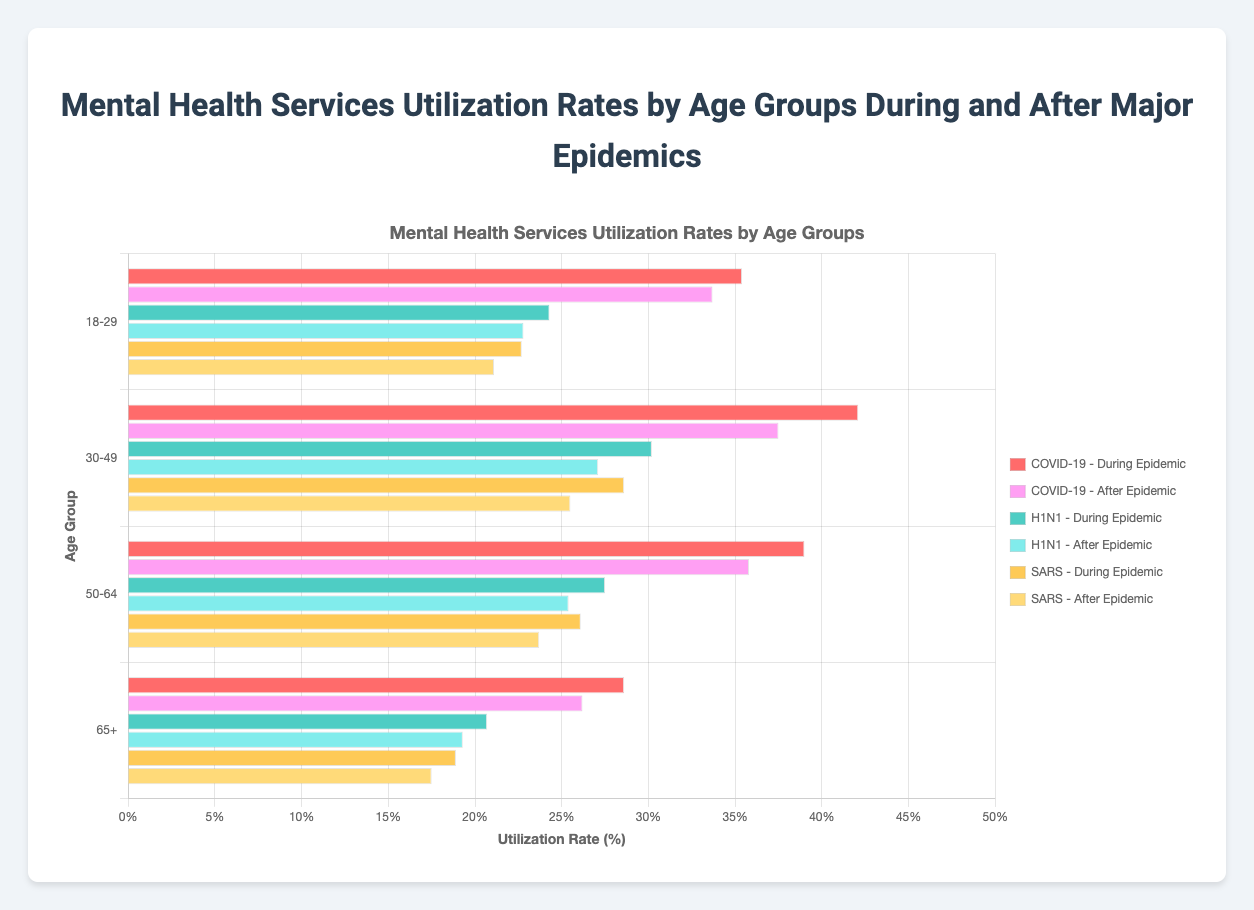Which age group had the highest utilization rate during the COVID-19 epidemic? To find the age group with the highest utilization rate during the COVID-19 epidemic, look for the highest bar that corresponds to the "During Epidemic" period for "COVID-19". The age group 30-49 has the highest utilization rate at 42.1%.
Answer: 30-49 What is the difference in utilization rates of mental health services between the 18-29 age group and the 65+ age group after the H1N1 epidemic? Find the utilization rates for both age groups after the H1N1 epidemic. For the 18-29 age group, the rate is 22.8%, and for the 65+ age group, it is 19.3%. The difference is 22.8% - 19.3% = 3.5%.
Answer: 3.5% During the SARS epidemic, which age group had the lowest utilization rate? Look for the lowest bar corresponding to the "During Epidemic" period for "SARS". The lowest utilization rate during the SARS epidemic is for the 65+ age group, which is 18.9%.
Answer: 65+ On average, how did the utilization rates for mental health services change for the age group 50-64 from during to after the COVID-19 epidemic? Find the utilization rates for the 50-64 age group during and after the COVID-19 epidemic. During the COVID-19 epidemic, the rate is 39.0%, and after the epidemic, it is 35.8%. The average change is calculated as (39.0% - 35.8%) / 2 = 1.6%.
Answer: 1.6% During the H1N1 epidemic, which age group had a higher utilization rate: 18-29 or 30-49? Compare the utilization rates during the H1N1 epidemic for the age groups 18-29 and 30-49. The 18-29 age group had a rate of 24.3% while the 30-49 age group had a rate of 30.2%. The 30-49 age group had a higher utilization rate.
Answer: 30-49 What is the total utilization rate for mental health services for the 30-49 age group during all three epidemics? Find the utilization rates for the 30-49 age group during each epidemic (COVID-19, H1N1, SARS). Add these rates: 42.1% (COVID-19) + 30.2% (H1N1) + 28.6% (SARS) = 100.9%.
Answer: 100.9% What was the average utilization rate for the 65+ age group after all three epidemics? Find the utilization rates for the 65+ age group after each epidemic (COVID-19, H1N1, SARS). Calculate the average: (26.2% + 19.3% + 17.5%) / 3 = 21.0%.
Answer: 21.0% Which age group had the most significant decrease in utilization rates from during to after the SARS epidemic? Look at the utilization rates for each age group during and after the SARS epidemic and calculate the decrease. The decreases are: 18-29: 22.7% to 21.1% (1.6%), 30-49: 28.6% to 25.5% (3.1%), 50-64: 26.1% to 23.7% (2.4%), 65+: 18.9% to 17.5% (1.4%). The 30-49 age group had the most significant decrease of 3.1%.
Answer: 30-49 What is the difference in the highest utilization rate between the COVID-19 and H1N1 epidemics for any age group? Find the highest utilization rate during the COVID-19 epidemic (42.1% for 30-49) and the highest rate during the H1N1 epidemic (30.2% for 30-49). The difference is 42.1% - 30.2% = 11.9%.
Answer: 11.9% 